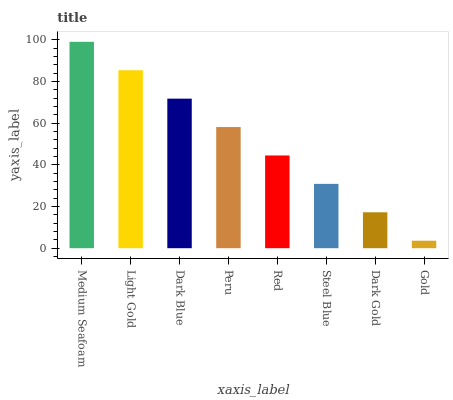Is Light Gold the minimum?
Answer yes or no. No. Is Light Gold the maximum?
Answer yes or no. No. Is Medium Seafoam greater than Light Gold?
Answer yes or no. Yes. Is Light Gold less than Medium Seafoam?
Answer yes or no. Yes. Is Light Gold greater than Medium Seafoam?
Answer yes or no. No. Is Medium Seafoam less than Light Gold?
Answer yes or no. No. Is Peru the high median?
Answer yes or no. Yes. Is Red the low median?
Answer yes or no. Yes. Is Steel Blue the high median?
Answer yes or no. No. Is Dark Gold the low median?
Answer yes or no. No. 